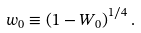<formula> <loc_0><loc_0><loc_500><loc_500>w _ { 0 } \equiv \left ( 1 - W _ { 0 } \right ) ^ { 1 / 4 } .</formula> 